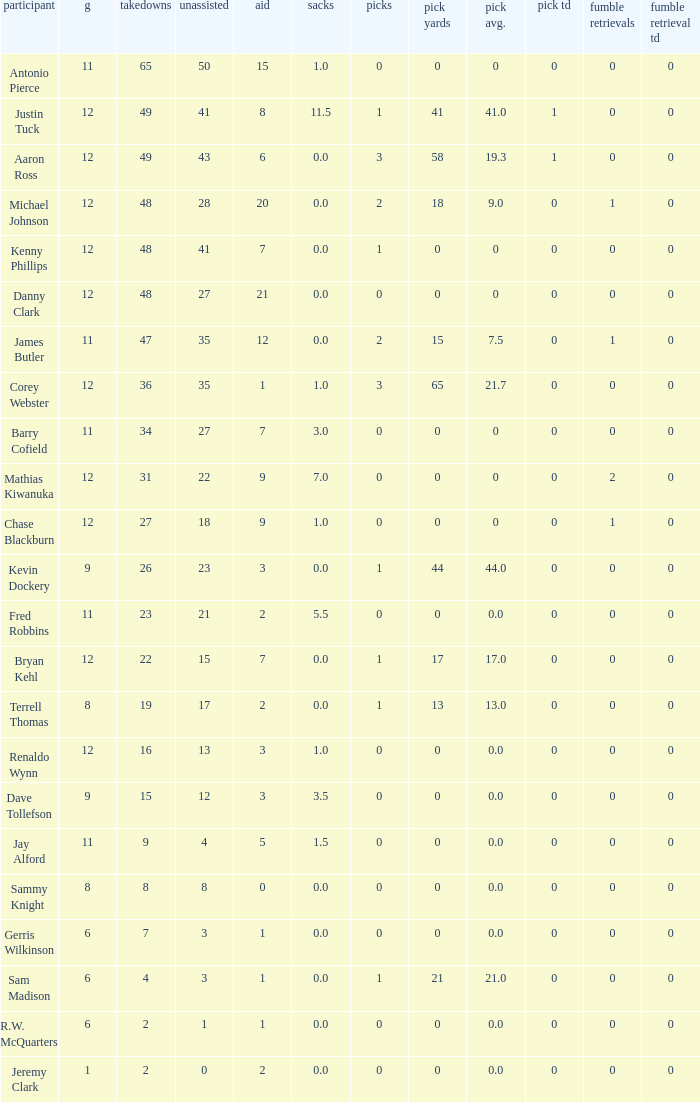Name the least amount of tackles for danny clark 48.0. 